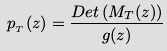<formula> <loc_0><loc_0><loc_500><loc_500>p _ { _ { T } } ( z ) = \frac { D e t \left ( M _ { T } ( z ) \right ) } { g ( z ) }</formula> 